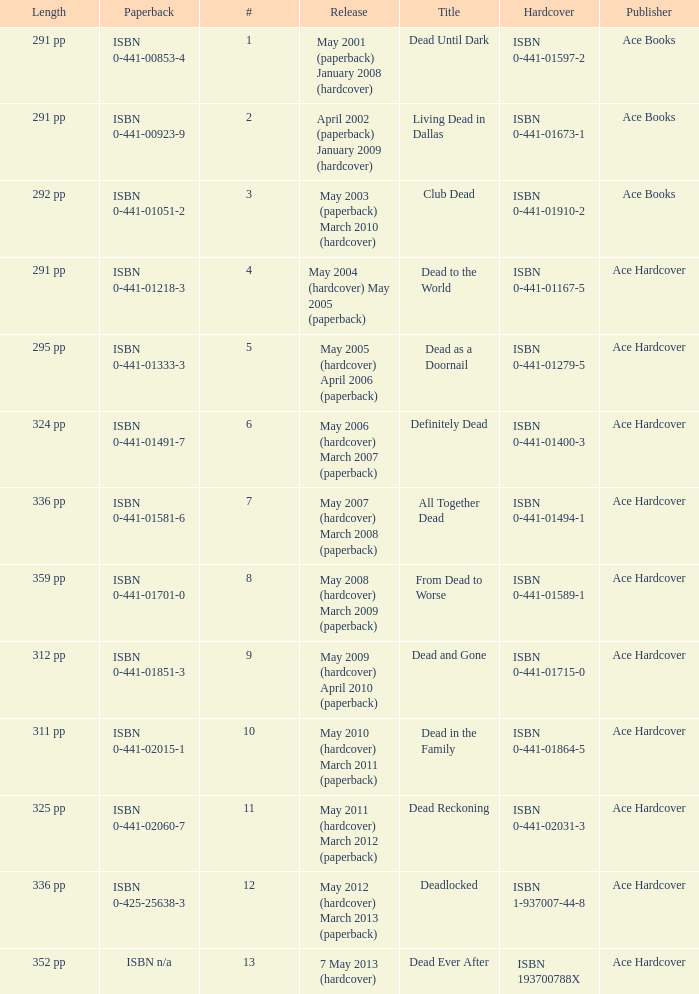What is the ISBN of "Dead as a Doornail? ISBN 0-441-01333-3. 